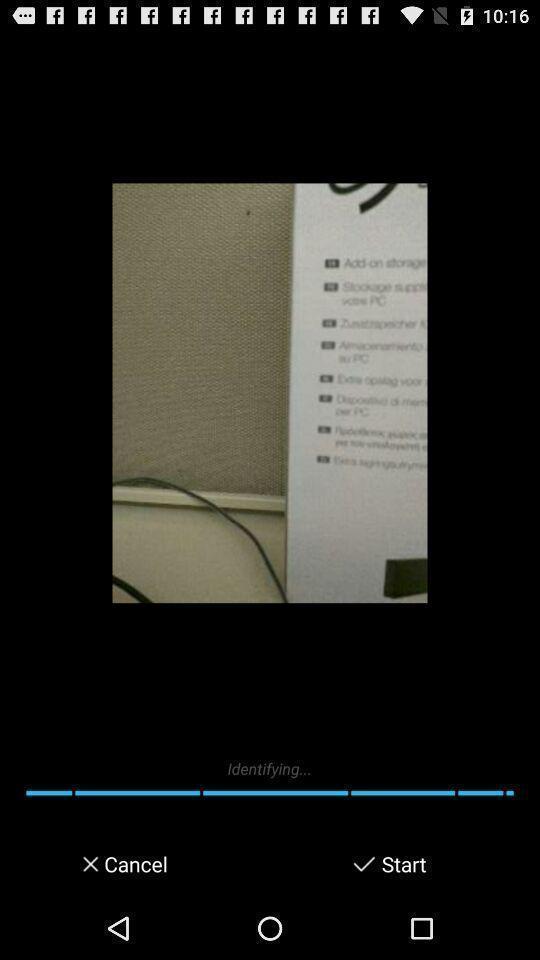Summarize the information in this screenshot. Page with an image. 